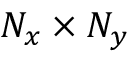<formula> <loc_0><loc_0><loc_500><loc_500>N _ { x } \times N _ { y }</formula> 